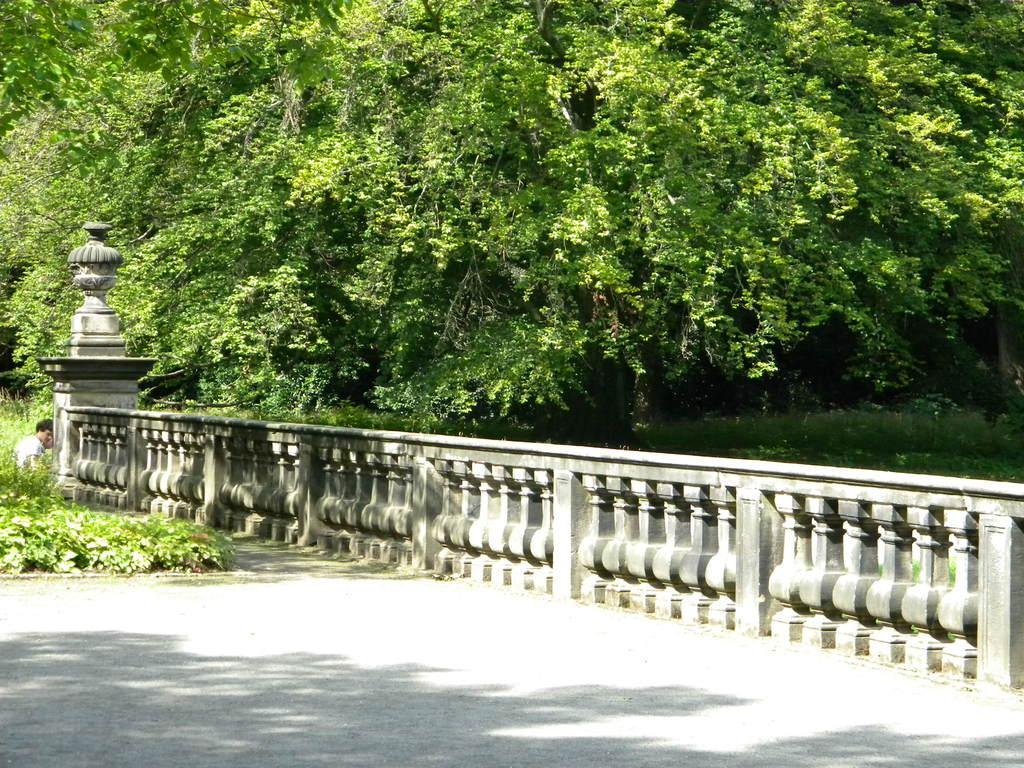Describe this image in one or two sentences. In this image I can see a fence, plants and a person over here. In the background I can see trees. 